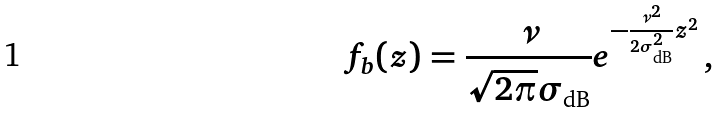<formula> <loc_0><loc_0><loc_500><loc_500>f _ { b } ( z ) = \frac { \nu } { \sqrt { 2 \pi } \sigma _ { \text {dB} } } e ^ { - \frac { \nu ^ { 2 } } { 2 \sigma _ { \text {dB} } ^ { 2 } } z ^ { 2 } } \, ,</formula> 